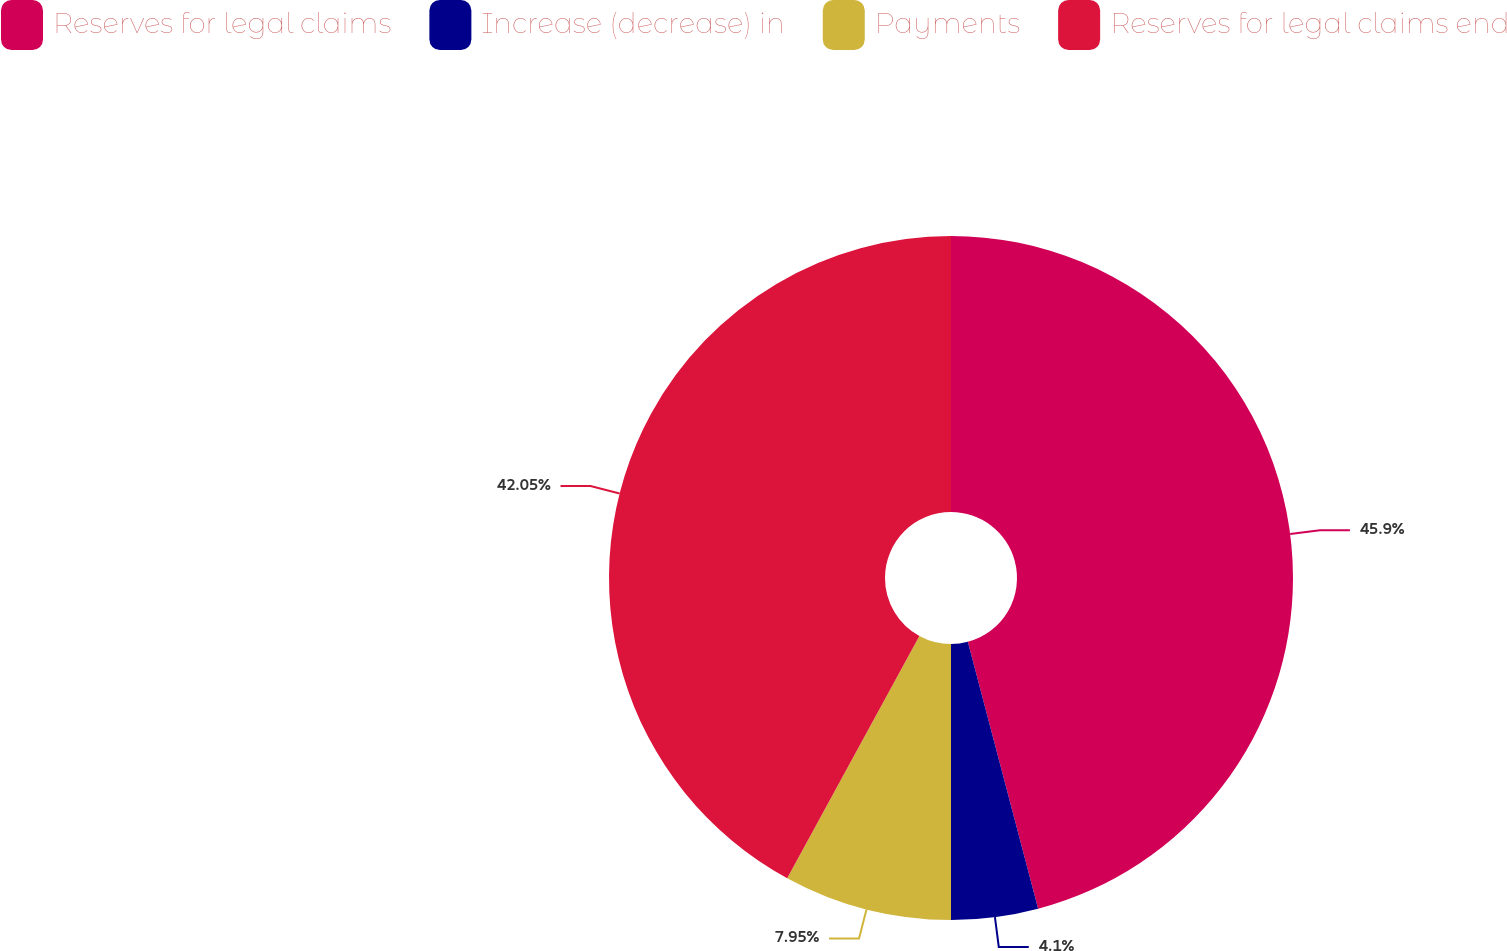Convert chart. <chart><loc_0><loc_0><loc_500><loc_500><pie_chart><fcel>Reserves for legal claims<fcel>Increase (decrease) in<fcel>Payments<fcel>Reserves for legal claims end<nl><fcel>45.9%<fcel>4.1%<fcel>7.95%<fcel>42.05%<nl></chart> 